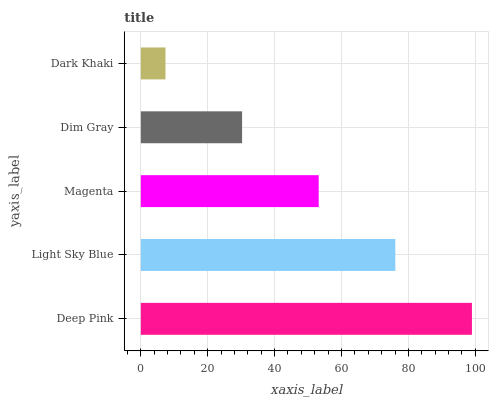Is Dark Khaki the minimum?
Answer yes or no. Yes. Is Deep Pink the maximum?
Answer yes or no. Yes. Is Light Sky Blue the minimum?
Answer yes or no. No. Is Light Sky Blue the maximum?
Answer yes or no. No. Is Deep Pink greater than Light Sky Blue?
Answer yes or no. Yes. Is Light Sky Blue less than Deep Pink?
Answer yes or no. Yes. Is Light Sky Blue greater than Deep Pink?
Answer yes or no. No. Is Deep Pink less than Light Sky Blue?
Answer yes or no. No. Is Magenta the high median?
Answer yes or no. Yes. Is Magenta the low median?
Answer yes or no. Yes. Is Dark Khaki the high median?
Answer yes or no. No. Is Dim Gray the low median?
Answer yes or no. No. 